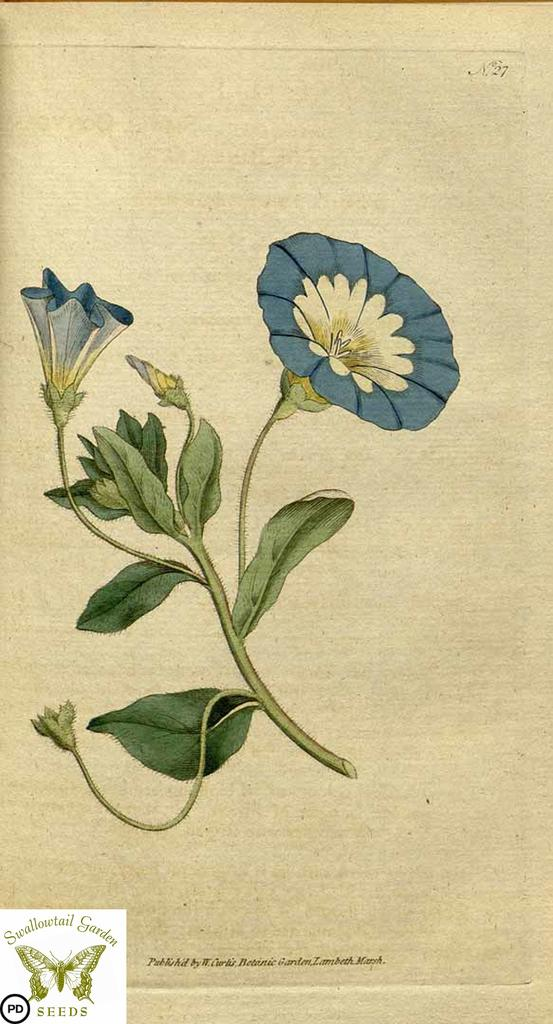What is depicted in the painting in the image? There is a painting of a flower in the image. Can you describe any additional features of the image? There is a watermark on the image. What type of iron can be seen in the image? There is no iron present in the image; it only contains a painting of a flower and a watermark. 